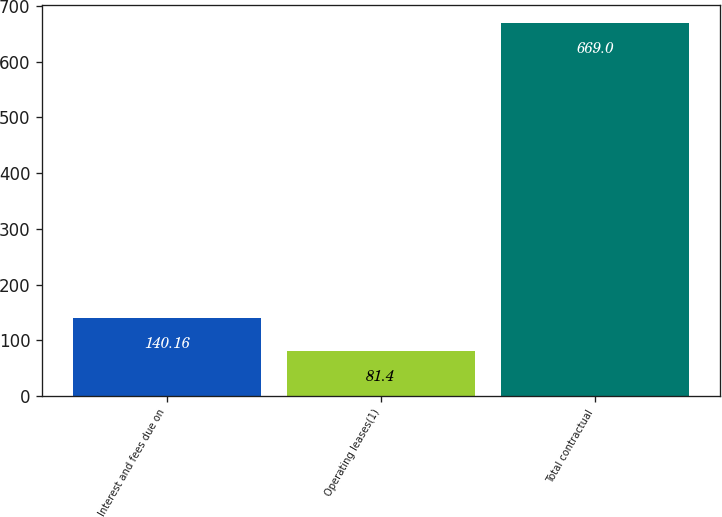Convert chart to OTSL. <chart><loc_0><loc_0><loc_500><loc_500><bar_chart><fcel>Interest and fees due on<fcel>Operating leases(1)<fcel>Total contractual<nl><fcel>140.16<fcel>81.4<fcel>669<nl></chart> 